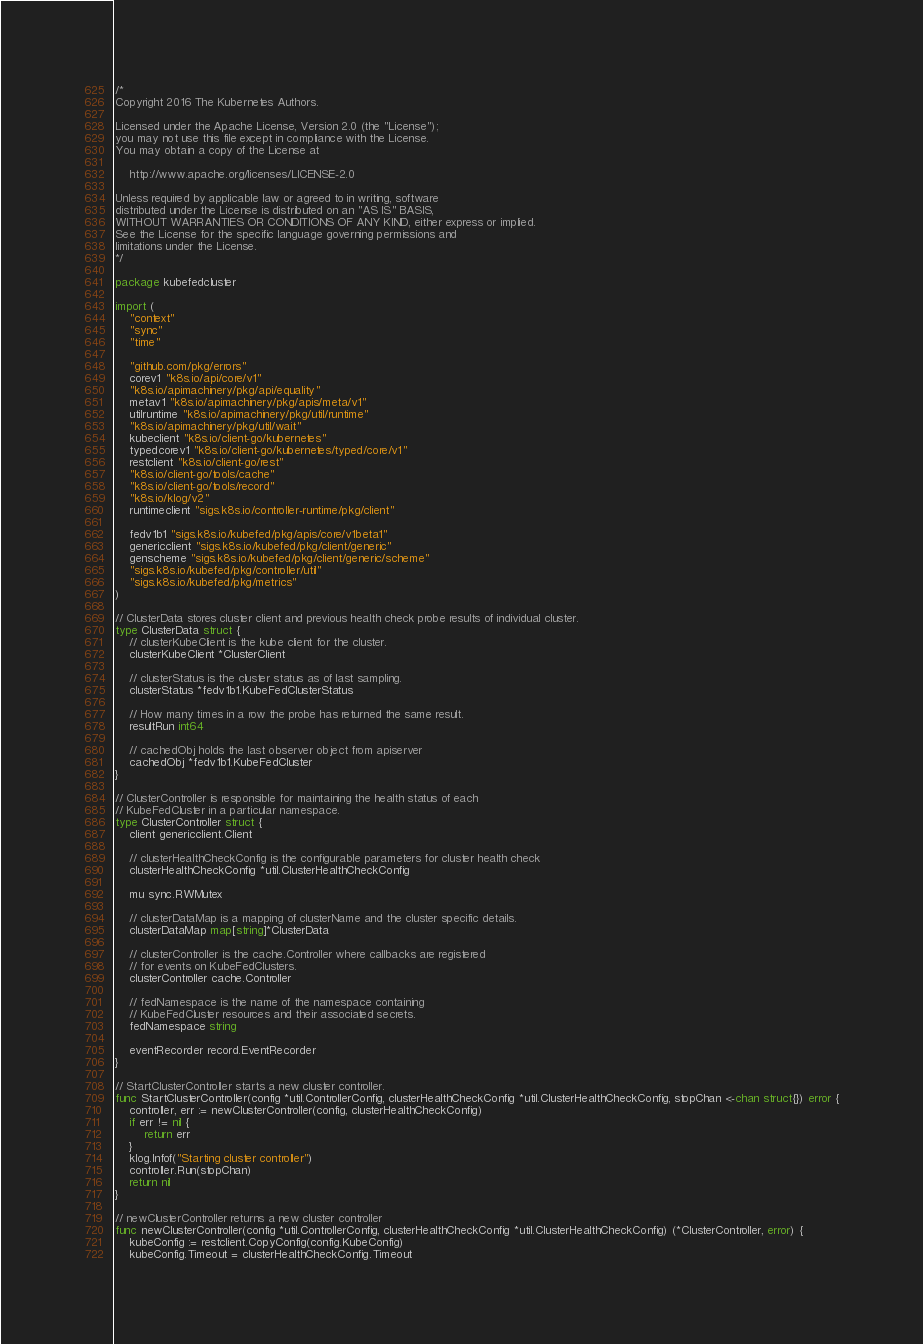<code> <loc_0><loc_0><loc_500><loc_500><_Go_>/*
Copyright 2016 The Kubernetes Authors.

Licensed under the Apache License, Version 2.0 (the "License");
you may not use this file except in compliance with the License.
You may obtain a copy of the License at

    http://www.apache.org/licenses/LICENSE-2.0

Unless required by applicable law or agreed to in writing, software
distributed under the License is distributed on an "AS IS" BASIS,
WITHOUT WARRANTIES OR CONDITIONS OF ANY KIND, either express or implied.
See the License for the specific language governing permissions and
limitations under the License.
*/

package kubefedcluster

import (
	"context"
	"sync"
	"time"

	"github.com/pkg/errors"
	corev1 "k8s.io/api/core/v1"
	"k8s.io/apimachinery/pkg/api/equality"
	metav1 "k8s.io/apimachinery/pkg/apis/meta/v1"
	utilruntime "k8s.io/apimachinery/pkg/util/runtime"
	"k8s.io/apimachinery/pkg/util/wait"
	kubeclient "k8s.io/client-go/kubernetes"
	typedcorev1 "k8s.io/client-go/kubernetes/typed/core/v1"
	restclient "k8s.io/client-go/rest"
	"k8s.io/client-go/tools/cache"
	"k8s.io/client-go/tools/record"
	"k8s.io/klog/v2"
	runtimeclient "sigs.k8s.io/controller-runtime/pkg/client"

	fedv1b1 "sigs.k8s.io/kubefed/pkg/apis/core/v1beta1"
	genericclient "sigs.k8s.io/kubefed/pkg/client/generic"
	genscheme "sigs.k8s.io/kubefed/pkg/client/generic/scheme"
	"sigs.k8s.io/kubefed/pkg/controller/util"
	"sigs.k8s.io/kubefed/pkg/metrics"
)

// ClusterData stores cluster client and previous health check probe results of individual cluster.
type ClusterData struct {
	// clusterKubeClient is the kube client for the cluster.
	clusterKubeClient *ClusterClient

	// clusterStatus is the cluster status as of last sampling.
	clusterStatus *fedv1b1.KubeFedClusterStatus

	// How many times in a row the probe has returned the same result.
	resultRun int64

	// cachedObj holds the last observer object from apiserver
	cachedObj *fedv1b1.KubeFedCluster
}

// ClusterController is responsible for maintaining the health status of each
// KubeFedCluster in a particular namespace.
type ClusterController struct {
	client genericclient.Client

	// clusterHealthCheckConfig is the configurable parameters for cluster health check
	clusterHealthCheckConfig *util.ClusterHealthCheckConfig

	mu sync.RWMutex

	// clusterDataMap is a mapping of clusterName and the cluster specific details.
	clusterDataMap map[string]*ClusterData

	// clusterController is the cache.Controller where callbacks are registered
	// for events on KubeFedClusters.
	clusterController cache.Controller

	// fedNamespace is the name of the namespace containing
	// KubeFedCluster resources and their associated secrets.
	fedNamespace string

	eventRecorder record.EventRecorder
}

// StartClusterController starts a new cluster controller.
func StartClusterController(config *util.ControllerConfig, clusterHealthCheckConfig *util.ClusterHealthCheckConfig, stopChan <-chan struct{}) error {
	controller, err := newClusterController(config, clusterHealthCheckConfig)
	if err != nil {
		return err
	}
	klog.Infof("Starting cluster controller")
	controller.Run(stopChan)
	return nil
}

// newClusterController returns a new cluster controller
func newClusterController(config *util.ControllerConfig, clusterHealthCheckConfig *util.ClusterHealthCheckConfig) (*ClusterController, error) {
	kubeConfig := restclient.CopyConfig(config.KubeConfig)
	kubeConfig.Timeout = clusterHealthCheckConfig.Timeout</code> 